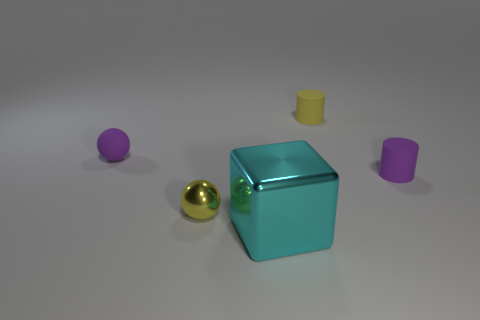Does the large thing have the same shape as the yellow metal object?
Provide a succinct answer. No. How many small matte cylinders are right of the small sphere that is behind the tiny yellow sphere?
Provide a short and direct response. 2. There is another thing that is the same shape as the small metal object; what is it made of?
Give a very brief answer. Rubber. Does the tiny matte thing that is to the right of the yellow cylinder have the same color as the large block?
Your answer should be compact. No. Does the tiny yellow cylinder have the same material as the tiny thing on the left side of the tiny yellow sphere?
Provide a short and direct response. Yes. What is the shape of the purple object that is right of the purple sphere?
Keep it short and to the point. Cylinder. What number of other objects are there of the same material as the purple cylinder?
Provide a succinct answer. 2. The cyan block is what size?
Provide a succinct answer. Large. How many other things are there of the same color as the large thing?
Provide a short and direct response. 0. What color is the object that is both in front of the small purple matte ball and left of the cyan shiny thing?
Give a very brief answer. Yellow. 